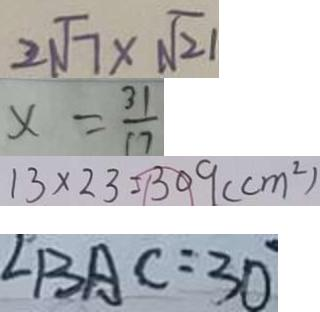<formula> <loc_0><loc_0><loc_500><loc_500>2 \sqrt { 7 } \times \sqrt { 2 1 } 
 x = \frac { 3 1 } { 1 7 } 
 1 3 \times 2 3 = 3 0 9 ( c m ^ { 2 } ) 
 \angle B A C = 3 0</formula> 